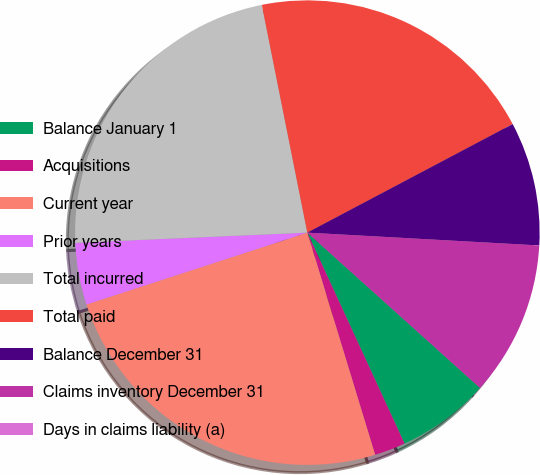<chart> <loc_0><loc_0><loc_500><loc_500><pie_chart><fcel>Balance January 1<fcel>Acquisitions<fcel>Current year<fcel>Prior years<fcel>Total incurred<fcel>Total paid<fcel>Balance December 31<fcel>Claims inventory December 31<fcel>Days in claims liability (a)<nl><fcel>6.47%<fcel>2.16%<fcel>24.71%<fcel>4.31%<fcel>22.56%<fcel>20.4%<fcel>8.62%<fcel>10.78%<fcel>0.0%<nl></chart> 